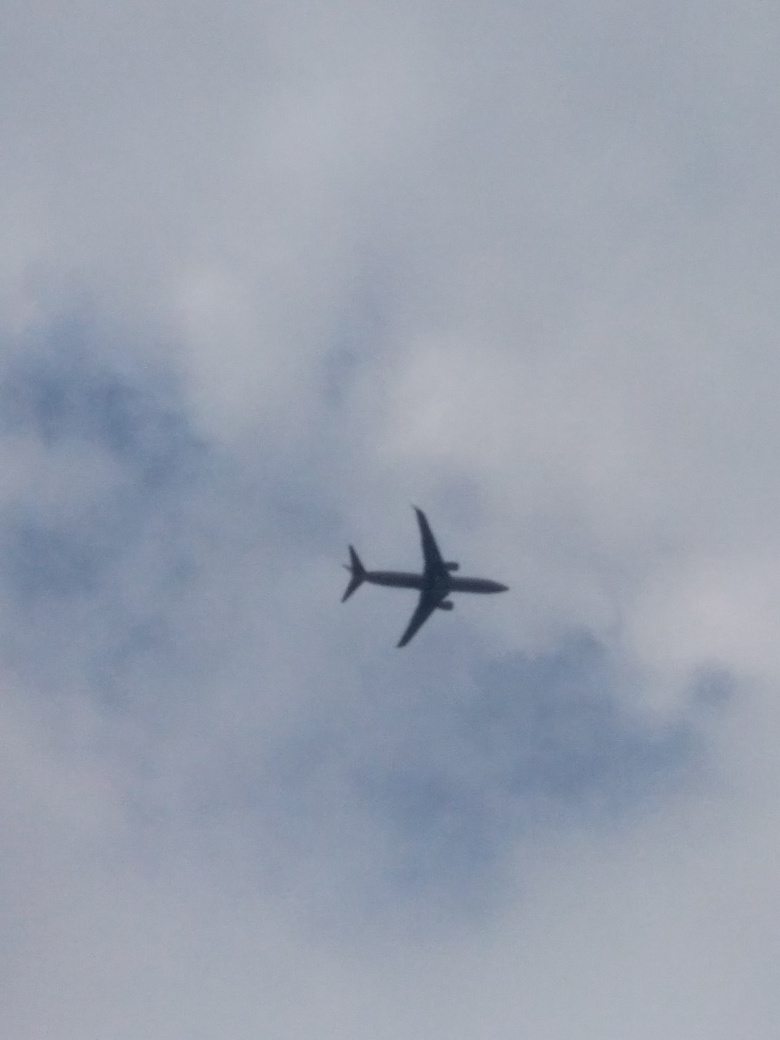Why is the scene dim in this image? The scene appears dim due to the subdued natural light, which is most likely a result of overcast conditions, thick clouds, or the time of day being either early morning or late afternoon when the sun is not as bright. 